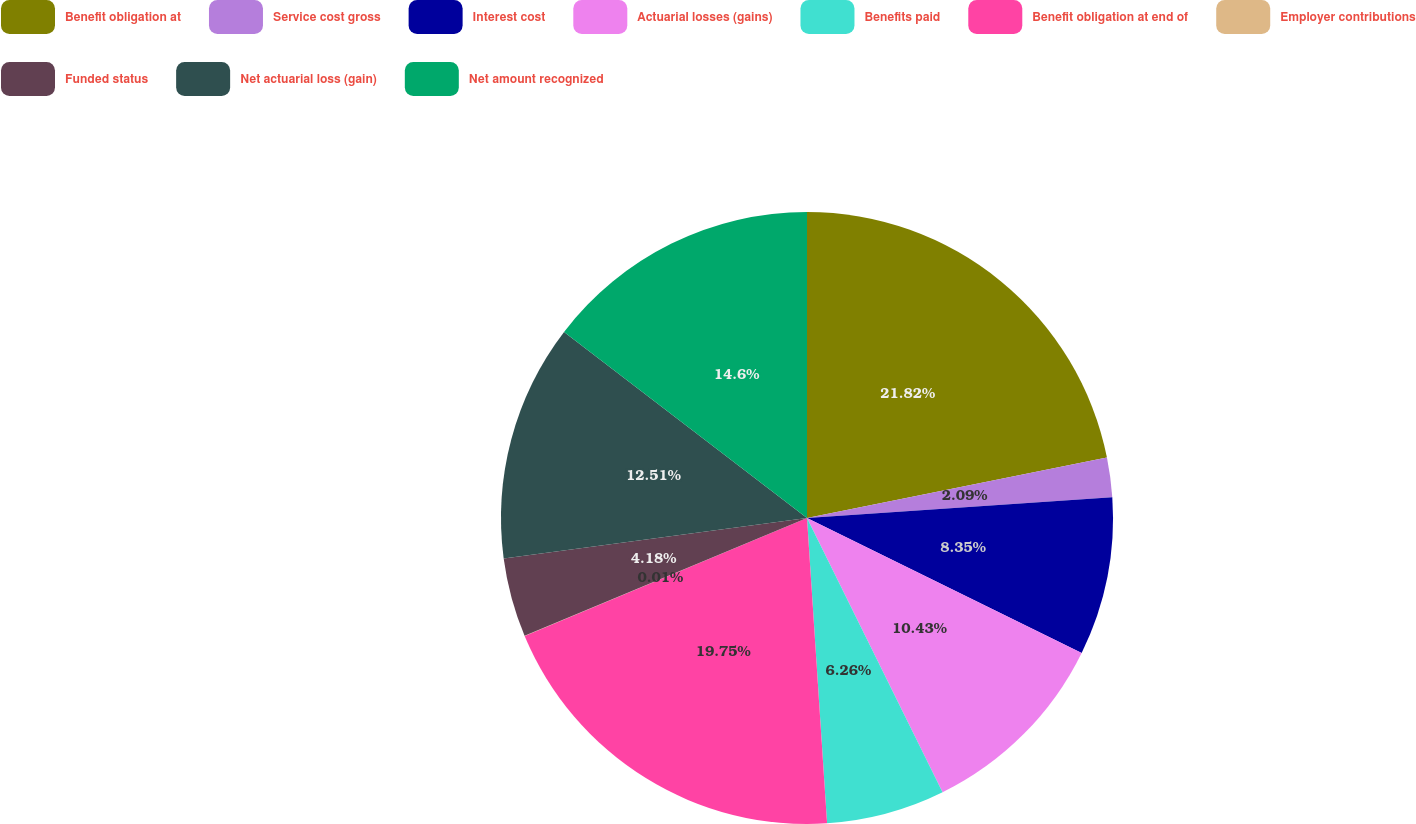<chart> <loc_0><loc_0><loc_500><loc_500><pie_chart><fcel>Benefit obligation at<fcel>Service cost gross<fcel>Interest cost<fcel>Actuarial losses (gains)<fcel>Benefits paid<fcel>Benefit obligation at end of<fcel>Employer contributions<fcel>Funded status<fcel>Net actuarial loss (gain)<fcel>Net amount recognized<nl><fcel>21.83%<fcel>2.09%<fcel>8.35%<fcel>10.43%<fcel>6.26%<fcel>19.75%<fcel>0.01%<fcel>4.18%<fcel>12.51%<fcel>14.6%<nl></chart> 